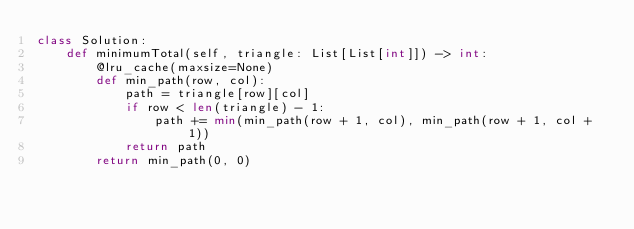Convert code to text. <code><loc_0><loc_0><loc_500><loc_500><_Python_>class Solution:
    def minimumTotal(self, triangle: List[List[int]]) -> int:
        @lru_cache(maxsize=None)
        def min_path(row, col):
            path = triangle[row][col]
            if row < len(triangle) - 1:
                path += min(min_path(row + 1, col), min_path(row + 1, col + 1))
            return path
        return min_path(0, 0)
</code> 